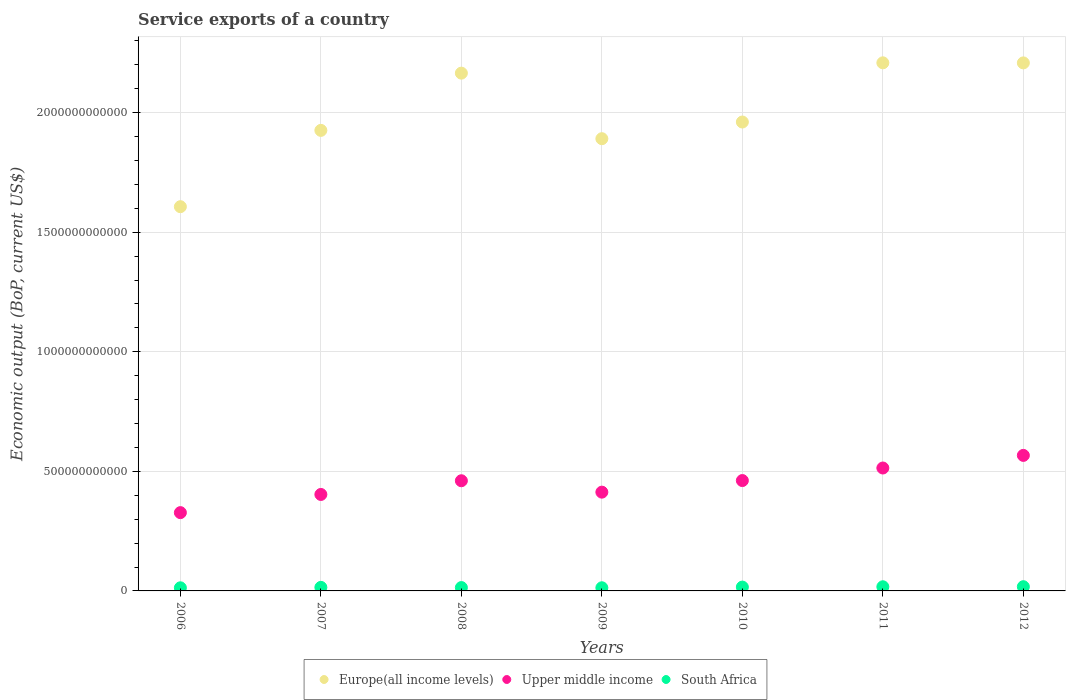How many different coloured dotlines are there?
Your response must be concise. 3. What is the service exports in Europe(all income levels) in 2012?
Provide a short and direct response. 2.21e+12. Across all years, what is the maximum service exports in Europe(all income levels)?
Your answer should be compact. 2.21e+12. Across all years, what is the minimum service exports in South Africa?
Provide a succinct answer. 1.31e+1. In which year was the service exports in South Africa minimum?
Your answer should be very brief. 2006. What is the total service exports in Europe(all income levels) in the graph?
Give a very brief answer. 1.40e+13. What is the difference between the service exports in Upper middle income in 2011 and that in 2012?
Keep it short and to the point. -5.27e+1. What is the difference between the service exports in South Africa in 2006 and the service exports in Upper middle income in 2010?
Your response must be concise. -4.48e+11. What is the average service exports in Europe(all income levels) per year?
Provide a short and direct response. 2.00e+12. In the year 2011, what is the difference between the service exports in Europe(all income levels) and service exports in Upper middle income?
Offer a terse response. 1.69e+12. What is the ratio of the service exports in Europe(all income levels) in 2008 to that in 2012?
Make the answer very short. 0.98. Is the service exports in Upper middle income in 2007 less than that in 2010?
Provide a succinct answer. Yes. Is the difference between the service exports in Europe(all income levels) in 2006 and 2008 greater than the difference between the service exports in Upper middle income in 2006 and 2008?
Your response must be concise. No. What is the difference between the highest and the second highest service exports in Upper middle income?
Your answer should be compact. 5.27e+1. What is the difference between the highest and the lowest service exports in Upper middle income?
Provide a succinct answer. 2.39e+11. Is it the case that in every year, the sum of the service exports in Europe(all income levels) and service exports in South Africa  is greater than the service exports in Upper middle income?
Your answer should be very brief. Yes. Is the service exports in Upper middle income strictly greater than the service exports in South Africa over the years?
Give a very brief answer. Yes. Is the service exports in Upper middle income strictly less than the service exports in South Africa over the years?
Ensure brevity in your answer.  No. How many dotlines are there?
Ensure brevity in your answer.  3. How many years are there in the graph?
Your response must be concise. 7. What is the difference between two consecutive major ticks on the Y-axis?
Keep it short and to the point. 5.00e+11. Are the values on the major ticks of Y-axis written in scientific E-notation?
Provide a short and direct response. No. Does the graph contain any zero values?
Provide a short and direct response. No. Does the graph contain grids?
Keep it short and to the point. Yes. How many legend labels are there?
Keep it short and to the point. 3. What is the title of the graph?
Offer a terse response. Service exports of a country. What is the label or title of the Y-axis?
Make the answer very short. Economic output (BoP, current US$). What is the Economic output (BoP, current US$) of Europe(all income levels) in 2006?
Provide a short and direct response. 1.61e+12. What is the Economic output (BoP, current US$) of Upper middle income in 2006?
Your answer should be very brief. 3.27e+11. What is the Economic output (BoP, current US$) of South Africa in 2006?
Offer a terse response. 1.31e+1. What is the Economic output (BoP, current US$) in Europe(all income levels) in 2007?
Ensure brevity in your answer.  1.93e+12. What is the Economic output (BoP, current US$) of Upper middle income in 2007?
Offer a very short reply. 4.03e+11. What is the Economic output (BoP, current US$) in South Africa in 2007?
Your answer should be compact. 1.48e+1. What is the Economic output (BoP, current US$) in Europe(all income levels) in 2008?
Give a very brief answer. 2.17e+12. What is the Economic output (BoP, current US$) in Upper middle income in 2008?
Give a very brief answer. 4.61e+11. What is the Economic output (BoP, current US$) in South Africa in 2008?
Your answer should be compact. 1.40e+1. What is the Economic output (BoP, current US$) in Europe(all income levels) in 2009?
Keep it short and to the point. 1.89e+12. What is the Economic output (BoP, current US$) in Upper middle income in 2009?
Your answer should be very brief. 4.13e+11. What is the Economic output (BoP, current US$) in South Africa in 2009?
Provide a succinct answer. 1.32e+1. What is the Economic output (BoP, current US$) in Europe(all income levels) in 2010?
Ensure brevity in your answer.  1.96e+12. What is the Economic output (BoP, current US$) of Upper middle income in 2010?
Your response must be concise. 4.62e+11. What is the Economic output (BoP, current US$) in South Africa in 2010?
Offer a very short reply. 1.61e+1. What is the Economic output (BoP, current US$) of Europe(all income levels) in 2011?
Keep it short and to the point. 2.21e+12. What is the Economic output (BoP, current US$) in Upper middle income in 2011?
Provide a succinct answer. 5.14e+11. What is the Economic output (BoP, current US$) of South Africa in 2011?
Give a very brief answer. 1.73e+1. What is the Economic output (BoP, current US$) in Europe(all income levels) in 2012?
Provide a succinct answer. 2.21e+12. What is the Economic output (BoP, current US$) in Upper middle income in 2012?
Your answer should be very brief. 5.67e+11. What is the Economic output (BoP, current US$) of South Africa in 2012?
Your answer should be very brief. 1.76e+1. Across all years, what is the maximum Economic output (BoP, current US$) of Europe(all income levels)?
Offer a terse response. 2.21e+12. Across all years, what is the maximum Economic output (BoP, current US$) in Upper middle income?
Provide a short and direct response. 5.67e+11. Across all years, what is the maximum Economic output (BoP, current US$) of South Africa?
Your answer should be very brief. 1.76e+1. Across all years, what is the minimum Economic output (BoP, current US$) in Europe(all income levels)?
Your answer should be very brief. 1.61e+12. Across all years, what is the minimum Economic output (BoP, current US$) in Upper middle income?
Keep it short and to the point. 3.27e+11. Across all years, what is the minimum Economic output (BoP, current US$) of South Africa?
Ensure brevity in your answer.  1.31e+1. What is the total Economic output (BoP, current US$) in Europe(all income levels) in the graph?
Provide a short and direct response. 1.40e+13. What is the total Economic output (BoP, current US$) in Upper middle income in the graph?
Keep it short and to the point. 3.15e+12. What is the total Economic output (BoP, current US$) of South Africa in the graph?
Your answer should be very brief. 1.06e+11. What is the difference between the Economic output (BoP, current US$) in Europe(all income levels) in 2006 and that in 2007?
Your answer should be very brief. -3.19e+11. What is the difference between the Economic output (BoP, current US$) in Upper middle income in 2006 and that in 2007?
Offer a very short reply. -7.60e+1. What is the difference between the Economic output (BoP, current US$) of South Africa in 2006 and that in 2007?
Make the answer very short. -1.78e+09. What is the difference between the Economic output (BoP, current US$) of Europe(all income levels) in 2006 and that in 2008?
Ensure brevity in your answer.  -5.58e+11. What is the difference between the Economic output (BoP, current US$) in Upper middle income in 2006 and that in 2008?
Offer a very short reply. -1.33e+11. What is the difference between the Economic output (BoP, current US$) of South Africa in 2006 and that in 2008?
Keep it short and to the point. -9.40e+08. What is the difference between the Economic output (BoP, current US$) of Europe(all income levels) in 2006 and that in 2009?
Offer a very short reply. -2.84e+11. What is the difference between the Economic output (BoP, current US$) in Upper middle income in 2006 and that in 2009?
Provide a short and direct response. -8.56e+1. What is the difference between the Economic output (BoP, current US$) of South Africa in 2006 and that in 2009?
Ensure brevity in your answer.  -1.42e+08. What is the difference between the Economic output (BoP, current US$) of Europe(all income levels) in 2006 and that in 2010?
Give a very brief answer. -3.54e+11. What is the difference between the Economic output (BoP, current US$) of Upper middle income in 2006 and that in 2010?
Offer a very short reply. -1.34e+11. What is the difference between the Economic output (BoP, current US$) of South Africa in 2006 and that in 2010?
Ensure brevity in your answer.  -3.00e+09. What is the difference between the Economic output (BoP, current US$) of Europe(all income levels) in 2006 and that in 2011?
Offer a terse response. -6.02e+11. What is the difference between the Economic output (BoP, current US$) of Upper middle income in 2006 and that in 2011?
Offer a terse response. -1.87e+11. What is the difference between the Economic output (BoP, current US$) of South Africa in 2006 and that in 2011?
Your response must be concise. -4.29e+09. What is the difference between the Economic output (BoP, current US$) of Europe(all income levels) in 2006 and that in 2012?
Your response must be concise. -6.01e+11. What is the difference between the Economic output (BoP, current US$) of Upper middle income in 2006 and that in 2012?
Your answer should be very brief. -2.39e+11. What is the difference between the Economic output (BoP, current US$) of South Africa in 2006 and that in 2012?
Provide a succinct answer. -4.58e+09. What is the difference between the Economic output (BoP, current US$) in Europe(all income levels) in 2007 and that in 2008?
Offer a very short reply. -2.39e+11. What is the difference between the Economic output (BoP, current US$) in Upper middle income in 2007 and that in 2008?
Give a very brief answer. -5.73e+1. What is the difference between the Economic output (BoP, current US$) in South Africa in 2007 and that in 2008?
Your answer should be very brief. 8.41e+08. What is the difference between the Economic output (BoP, current US$) in Europe(all income levels) in 2007 and that in 2009?
Your answer should be compact. 3.47e+1. What is the difference between the Economic output (BoP, current US$) in Upper middle income in 2007 and that in 2009?
Your response must be concise. -9.65e+09. What is the difference between the Economic output (BoP, current US$) of South Africa in 2007 and that in 2009?
Your response must be concise. 1.64e+09. What is the difference between the Economic output (BoP, current US$) of Europe(all income levels) in 2007 and that in 2010?
Keep it short and to the point. -3.50e+1. What is the difference between the Economic output (BoP, current US$) in Upper middle income in 2007 and that in 2010?
Your answer should be compact. -5.81e+1. What is the difference between the Economic output (BoP, current US$) in South Africa in 2007 and that in 2010?
Keep it short and to the point. -1.22e+09. What is the difference between the Economic output (BoP, current US$) of Europe(all income levels) in 2007 and that in 2011?
Your answer should be very brief. -2.83e+11. What is the difference between the Economic output (BoP, current US$) of Upper middle income in 2007 and that in 2011?
Make the answer very short. -1.11e+11. What is the difference between the Economic output (BoP, current US$) of South Africa in 2007 and that in 2011?
Offer a terse response. -2.51e+09. What is the difference between the Economic output (BoP, current US$) in Europe(all income levels) in 2007 and that in 2012?
Your answer should be compact. -2.82e+11. What is the difference between the Economic output (BoP, current US$) of Upper middle income in 2007 and that in 2012?
Provide a succinct answer. -1.63e+11. What is the difference between the Economic output (BoP, current US$) of South Africa in 2007 and that in 2012?
Your response must be concise. -2.80e+09. What is the difference between the Economic output (BoP, current US$) in Europe(all income levels) in 2008 and that in 2009?
Your answer should be compact. 2.74e+11. What is the difference between the Economic output (BoP, current US$) of Upper middle income in 2008 and that in 2009?
Your answer should be very brief. 4.77e+1. What is the difference between the Economic output (BoP, current US$) in South Africa in 2008 and that in 2009?
Your answer should be very brief. 7.98e+08. What is the difference between the Economic output (BoP, current US$) of Europe(all income levels) in 2008 and that in 2010?
Make the answer very short. 2.04e+11. What is the difference between the Economic output (BoP, current US$) in Upper middle income in 2008 and that in 2010?
Your response must be concise. -8.05e+08. What is the difference between the Economic output (BoP, current US$) of South Africa in 2008 and that in 2010?
Keep it short and to the point. -2.06e+09. What is the difference between the Economic output (BoP, current US$) in Europe(all income levels) in 2008 and that in 2011?
Offer a terse response. -4.32e+1. What is the difference between the Economic output (BoP, current US$) of Upper middle income in 2008 and that in 2011?
Your answer should be compact. -5.33e+1. What is the difference between the Economic output (BoP, current US$) in South Africa in 2008 and that in 2011?
Your answer should be compact. -3.35e+09. What is the difference between the Economic output (BoP, current US$) of Europe(all income levels) in 2008 and that in 2012?
Provide a succinct answer. -4.28e+1. What is the difference between the Economic output (BoP, current US$) in Upper middle income in 2008 and that in 2012?
Make the answer very short. -1.06e+11. What is the difference between the Economic output (BoP, current US$) in South Africa in 2008 and that in 2012?
Your answer should be compact. -3.64e+09. What is the difference between the Economic output (BoP, current US$) in Europe(all income levels) in 2009 and that in 2010?
Provide a succinct answer. -6.97e+1. What is the difference between the Economic output (BoP, current US$) of Upper middle income in 2009 and that in 2010?
Ensure brevity in your answer.  -4.85e+1. What is the difference between the Economic output (BoP, current US$) of South Africa in 2009 and that in 2010?
Make the answer very short. -2.86e+09. What is the difference between the Economic output (BoP, current US$) in Europe(all income levels) in 2009 and that in 2011?
Keep it short and to the point. -3.17e+11. What is the difference between the Economic output (BoP, current US$) in Upper middle income in 2009 and that in 2011?
Provide a short and direct response. -1.01e+11. What is the difference between the Economic output (BoP, current US$) in South Africa in 2009 and that in 2011?
Your answer should be compact. -4.15e+09. What is the difference between the Economic output (BoP, current US$) of Europe(all income levels) in 2009 and that in 2012?
Offer a very short reply. -3.17e+11. What is the difference between the Economic output (BoP, current US$) in Upper middle income in 2009 and that in 2012?
Provide a short and direct response. -1.54e+11. What is the difference between the Economic output (BoP, current US$) of South Africa in 2009 and that in 2012?
Offer a very short reply. -4.44e+09. What is the difference between the Economic output (BoP, current US$) of Europe(all income levels) in 2010 and that in 2011?
Your answer should be compact. -2.48e+11. What is the difference between the Economic output (BoP, current US$) of Upper middle income in 2010 and that in 2011?
Offer a very short reply. -5.25e+1. What is the difference between the Economic output (BoP, current US$) of South Africa in 2010 and that in 2011?
Make the answer very short. -1.28e+09. What is the difference between the Economic output (BoP, current US$) in Europe(all income levels) in 2010 and that in 2012?
Provide a short and direct response. -2.47e+11. What is the difference between the Economic output (BoP, current US$) of Upper middle income in 2010 and that in 2012?
Keep it short and to the point. -1.05e+11. What is the difference between the Economic output (BoP, current US$) of South Africa in 2010 and that in 2012?
Offer a terse response. -1.58e+09. What is the difference between the Economic output (BoP, current US$) in Europe(all income levels) in 2011 and that in 2012?
Your answer should be compact. 3.03e+08. What is the difference between the Economic output (BoP, current US$) of Upper middle income in 2011 and that in 2012?
Provide a succinct answer. -5.27e+1. What is the difference between the Economic output (BoP, current US$) in South Africa in 2011 and that in 2012?
Your answer should be very brief. -2.93e+08. What is the difference between the Economic output (BoP, current US$) of Europe(all income levels) in 2006 and the Economic output (BoP, current US$) of Upper middle income in 2007?
Ensure brevity in your answer.  1.20e+12. What is the difference between the Economic output (BoP, current US$) in Europe(all income levels) in 2006 and the Economic output (BoP, current US$) in South Africa in 2007?
Provide a short and direct response. 1.59e+12. What is the difference between the Economic output (BoP, current US$) of Upper middle income in 2006 and the Economic output (BoP, current US$) of South Africa in 2007?
Ensure brevity in your answer.  3.13e+11. What is the difference between the Economic output (BoP, current US$) in Europe(all income levels) in 2006 and the Economic output (BoP, current US$) in Upper middle income in 2008?
Keep it short and to the point. 1.15e+12. What is the difference between the Economic output (BoP, current US$) of Europe(all income levels) in 2006 and the Economic output (BoP, current US$) of South Africa in 2008?
Provide a succinct answer. 1.59e+12. What is the difference between the Economic output (BoP, current US$) of Upper middle income in 2006 and the Economic output (BoP, current US$) of South Africa in 2008?
Your answer should be very brief. 3.13e+11. What is the difference between the Economic output (BoP, current US$) of Europe(all income levels) in 2006 and the Economic output (BoP, current US$) of Upper middle income in 2009?
Provide a short and direct response. 1.19e+12. What is the difference between the Economic output (BoP, current US$) of Europe(all income levels) in 2006 and the Economic output (BoP, current US$) of South Africa in 2009?
Your answer should be very brief. 1.59e+12. What is the difference between the Economic output (BoP, current US$) in Upper middle income in 2006 and the Economic output (BoP, current US$) in South Africa in 2009?
Give a very brief answer. 3.14e+11. What is the difference between the Economic output (BoP, current US$) of Europe(all income levels) in 2006 and the Economic output (BoP, current US$) of Upper middle income in 2010?
Offer a terse response. 1.15e+12. What is the difference between the Economic output (BoP, current US$) in Europe(all income levels) in 2006 and the Economic output (BoP, current US$) in South Africa in 2010?
Provide a succinct answer. 1.59e+12. What is the difference between the Economic output (BoP, current US$) in Upper middle income in 2006 and the Economic output (BoP, current US$) in South Africa in 2010?
Ensure brevity in your answer.  3.11e+11. What is the difference between the Economic output (BoP, current US$) of Europe(all income levels) in 2006 and the Economic output (BoP, current US$) of Upper middle income in 2011?
Your response must be concise. 1.09e+12. What is the difference between the Economic output (BoP, current US$) of Europe(all income levels) in 2006 and the Economic output (BoP, current US$) of South Africa in 2011?
Your answer should be compact. 1.59e+12. What is the difference between the Economic output (BoP, current US$) of Upper middle income in 2006 and the Economic output (BoP, current US$) of South Africa in 2011?
Offer a very short reply. 3.10e+11. What is the difference between the Economic output (BoP, current US$) in Europe(all income levels) in 2006 and the Economic output (BoP, current US$) in Upper middle income in 2012?
Offer a very short reply. 1.04e+12. What is the difference between the Economic output (BoP, current US$) of Europe(all income levels) in 2006 and the Economic output (BoP, current US$) of South Africa in 2012?
Offer a terse response. 1.59e+12. What is the difference between the Economic output (BoP, current US$) of Upper middle income in 2006 and the Economic output (BoP, current US$) of South Africa in 2012?
Make the answer very short. 3.10e+11. What is the difference between the Economic output (BoP, current US$) of Europe(all income levels) in 2007 and the Economic output (BoP, current US$) of Upper middle income in 2008?
Ensure brevity in your answer.  1.47e+12. What is the difference between the Economic output (BoP, current US$) in Europe(all income levels) in 2007 and the Economic output (BoP, current US$) in South Africa in 2008?
Provide a short and direct response. 1.91e+12. What is the difference between the Economic output (BoP, current US$) in Upper middle income in 2007 and the Economic output (BoP, current US$) in South Africa in 2008?
Your answer should be very brief. 3.89e+11. What is the difference between the Economic output (BoP, current US$) in Europe(all income levels) in 2007 and the Economic output (BoP, current US$) in Upper middle income in 2009?
Offer a very short reply. 1.51e+12. What is the difference between the Economic output (BoP, current US$) of Europe(all income levels) in 2007 and the Economic output (BoP, current US$) of South Africa in 2009?
Your answer should be very brief. 1.91e+12. What is the difference between the Economic output (BoP, current US$) of Upper middle income in 2007 and the Economic output (BoP, current US$) of South Africa in 2009?
Your response must be concise. 3.90e+11. What is the difference between the Economic output (BoP, current US$) of Europe(all income levels) in 2007 and the Economic output (BoP, current US$) of Upper middle income in 2010?
Give a very brief answer. 1.46e+12. What is the difference between the Economic output (BoP, current US$) in Europe(all income levels) in 2007 and the Economic output (BoP, current US$) in South Africa in 2010?
Make the answer very short. 1.91e+12. What is the difference between the Economic output (BoP, current US$) of Upper middle income in 2007 and the Economic output (BoP, current US$) of South Africa in 2010?
Offer a terse response. 3.87e+11. What is the difference between the Economic output (BoP, current US$) of Europe(all income levels) in 2007 and the Economic output (BoP, current US$) of Upper middle income in 2011?
Your answer should be compact. 1.41e+12. What is the difference between the Economic output (BoP, current US$) in Europe(all income levels) in 2007 and the Economic output (BoP, current US$) in South Africa in 2011?
Make the answer very short. 1.91e+12. What is the difference between the Economic output (BoP, current US$) of Upper middle income in 2007 and the Economic output (BoP, current US$) of South Africa in 2011?
Give a very brief answer. 3.86e+11. What is the difference between the Economic output (BoP, current US$) of Europe(all income levels) in 2007 and the Economic output (BoP, current US$) of Upper middle income in 2012?
Keep it short and to the point. 1.36e+12. What is the difference between the Economic output (BoP, current US$) in Europe(all income levels) in 2007 and the Economic output (BoP, current US$) in South Africa in 2012?
Provide a short and direct response. 1.91e+12. What is the difference between the Economic output (BoP, current US$) in Upper middle income in 2007 and the Economic output (BoP, current US$) in South Africa in 2012?
Offer a very short reply. 3.86e+11. What is the difference between the Economic output (BoP, current US$) of Europe(all income levels) in 2008 and the Economic output (BoP, current US$) of Upper middle income in 2009?
Ensure brevity in your answer.  1.75e+12. What is the difference between the Economic output (BoP, current US$) in Europe(all income levels) in 2008 and the Economic output (BoP, current US$) in South Africa in 2009?
Ensure brevity in your answer.  2.15e+12. What is the difference between the Economic output (BoP, current US$) in Upper middle income in 2008 and the Economic output (BoP, current US$) in South Africa in 2009?
Provide a short and direct response. 4.48e+11. What is the difference between the Economic output (BoP, current US$) in Europe(all income levels) in 2008 and the Economic output (BoP, current US$) in Upper middle income in 2010?
Ensure brevity in your answer.  1.70e+12. What is the difference between the Economic output (BoP, current US$) of Europe(all income levels) in 2008 and the Economic output (BoP, current US$) of South Africa in 2010?
Your answer should be compact. 2.15e+12. What is the difference between the Economic output (BoP, current US$) of Upper middle income in 2008 and the Economic output (BoP, current US$) of South Africa in 2010?
Your answer should be compact. 4.45e+11. What is the difference between the Economic output (BoP, current US$) in Europe(all income levels) in 2008 and the Economic output (BoP, current US$) in Upper middle income in 2011?
Ensure brevity in your answer.  1.65e+12. What is the difference between the Economic output (BoP, current US$) in Europe(all income levels) in 2008 and the Economic output (BoP, current US$) in South Africa in 2011?
Your answer should be compact. 2.15e+12. What is the difference between the Economic output (BoP, current US$) of Upper middle income in 2008 and the Economic output (BoP, current US$) of South Africa in 2011?
Your answer should be compact. 4.43e+11. What is the difference between the Economic output (BoP, current US$) in Europe(all income levels) in 2008 and the Economic output (BoP, current US$) in Upper middle income in 2012?
Provide a short and direct response. 1.60e+12. What is the difference between the Economic output (BoP, current US$) of Europe(all income levels) in 2008 and the Economic output (BoP, current US$) of South Africa in 2012?
Your answer should be compact. 2.15e+12. What is the difference between the Economic output (BoP, current US$) of Upper middle income in 2008 and the Economic output (BoP, current US$) of South Africa in 2012?
Ensure brevity in your answer.  4.43e+11. What is the difference between the Economic output (BoP, current US$) in Europe(all income levels) in 2009 and the Economic output (BoP, current US$) in Upper middle income in 2010?
Provide a succinct answer. 1.43e+12. What is the difference between the Economic output (BoP, current US$) in Europe(all income levels) in 2009 and the Economic output (BoP, current US$) in South Africa in 2010?
Give a very brief answer. 1.88e+12. What is the difference between the Economic output (BoP, current US$) in Upper middle income in 2009 and the Economic output (BoP, current US$) in South Africa in 2010?
Offer a terse response. 3.97e+11. What is the difference between the Economic output (BoP, current US$) in Europe(all income levels) in 2009 and the Economic output (BoP, current US$) in Upper middle income in 2011?
Your response must be concise. 1.38e+12. What is the difference between the Economic output (BoP, current US$) in Europe(all income levels) in 2009 and the Economic output (BoP, current US$) in South Africa in 2011?
Ensure brevity in your answer.  1.87e+12. What is the difference between the Economic output (BoP, current US$) of Upper middle income in 2009 and the Economic output (BoP, current US$) of South Africa in 2011?
Offer a very short reply. 3.96e+11. What is the difference between the Economic output (BoP, current US$) in Europe(all income levels) in 2009 and the Economic output (BoP, current US$) in Upper middle income in 2012?
Ensure brevity in your answer.  1.32e+12. What is the difference between the Economic output (BoP, current US$) of Europe(all income levels) in 2009 and the Economic output (BoP, current US$) of South Africa in 2012?
Make the answer very short. 1.87e+12. What is the difference between the Economic output (BoP, current US$) of Upper middle income in 2009 and the Economic output (BoP, current US$) of South Africa in 2012?
Make the answer very short. 3.95e+11. What is the difference between the Economic output (BoP, current US$) of Europe(all income levels) in 2010 and the Economic output (BoP, current US$) of Upper middle income in 2011?
Offer a terse response. 1.45e+12. What is the difference between the Economic output (BoP, current US$) of Europe(all income levels) in 2010 and the Economic output (BoP, current US$) of South Africa in 2011?
Ensure brevity in your answer.  1.94e+12. What is the difference between the Economic output (BoP, current US$) of Upper middle income in 2010 and the Economic output (BoP, current US$) of South Africa in 2011?
Your response must be concise. 4.44e+11. What is the difference between the Economic output (BoP, current US$) of Europe(all income levels) in 2010 and the Economic output (BoP, current US$) of Upper middle income in 2012?
Your answer should be compact. 1.39e+12. What is the difference between the Economic output (BoP, current US$) in Europe(all income levels) in 2010 and the Economic output (BoP, current US$) in South Africa in 2012?
Give a very brief answer. 1.94e+12. What is the difference between the Economic output (BoP, current US$) of Upper middle income in 2010 and the Economic output (BoP, current US$) of South Africa in 2012?
Ensure brevity in your answer.  4.44e+11. What is the difference between the Economic output (BoP, current US$) in Europe(all income levels) in 2011 and the Economic output (BoP, current US$) in Upper middle income in 2012?
Your response must be concise. 1.64e+12. What is the difference between the Economic output (BoP, current US$) in Europe(all income levels) in 2011 and the Economic output (BoP, current US$) in South Africa in 2012?
Give a very brief answer. 2.19e+12. What is the difference between the Economic output (BoP, current US$) of Upper middle income in 2011 and the Economic output (BoP, current US$) of South Africa in 2012?
Offer a terse response. 4.96e+11. What is the average Economic output (BoP, current US$) of Europe(all income levels) per year?
Your response must be concise. 2.00e+12. What is the average Economic output (BoP, current US$) of Upper middle income per year?
Keep it short and to the point. 4.50e+11. What is the average Economic output (BoP, current US$) in South Africa per year?
Ensure brevity in your answer.  1.52e+1. In the year 2006, what is the difference between the Economic output (BoP, current US$) of Europe(all income levels) and Economic output (BoP, current US$) of Upper middle income?
Offer a terse response. 1.28e+12. In the year 2006, what is the difference between the Economic output (BoP, current US$) in Europe(all income levels) and Economic output (BoP, current US$) in South Africa?
Ensure brevity in your answer.  1.59e+12. In the year 2006, what is the difference between the Economic output (BoP, current US$) in Upper middle income and Economic output (BoP, current US$) in South Africa?
Your answer should be compact. 3.14e+11. In the year 2007, what is the difference between the Economic output (BoP, current US$) in Europe(all income levels) and Economic output (BoP, current US$) in Upper middle income?
Provide a succinct answer. 1.52e+12. In the year 2007, what is the difference between the Economic output (BoP, current US$) in Europe(all income levels) and Economic output (BoP, current US$) in South Africa?
Provide a short and direct response. 1.91e+12. In the year 2007, what is the difference between the Economic output (BoP, current US$) in Upper middle income and Economic output (BoP, current US$) in South Africa?
Offer a terse response. 3.89e+11. In the year 2008, what is the difference between the Economic output (BoP, current US$) in Europe(all income levels) and Economic output (BoP, current US$) in Upper middle income?
Your response must be concise. 1.70e+12. In the year 2008, what is the difference between the Economic output (BoP, current US$) of Europe(all income levels) and Economic output (BoP, current US$) of South Africa?
Offer a terse response. 2.15e+12. In the year 2008, what is the difference between the Economic output (BoP, current US$) of Upper middle income and Economic output (BoP, current US$) of South Africa?
Ensure brevity in your answer.  4.47e+11. In the year 2009, what is the difference between the Economic output (BoP, current US$) of Europe(all income levels) and Economic output (BoP, current US$) of Upper middle income?
Give a very brief answer. 1.48e+12. In the year 2009, what is the difference between the Economic output (BoP, current US$) of Europe(all income levels) and Economic output (BoP, current US$) of South Africa?
Give a very brief answer. 1.88e+12. In the year 2009, what is the difference between the Economic output (BoP, current US$) in Upper middle income and Economic output (BoP, current US$) in South Africa?
Provide a succinct answer. 4.00e+11. In the year 2010, what is the difference between the Economic output (BoP, current US$) in Europe(all income levels) and Economic output (BoP, current US$) in Upper middle income?
Your answer should be compact. 1.50e+12. In the year 2010, what is the difference between the Economic output (BoP, current US$) in Europe(all income levels) and Economic output (BoP, current US$) in South Africa?
Give a very brief answer. 1.94e+12. In the year 2010, what is the difference between the Economic output (BoP, current US$) of Upper middle income and Economic output (BoP, current US$) of South Africa?
Offer a terse response. 4.45e+11. In the year 2011, what is the difference between the Economic output (BoP, current US$) of Europe(all income levels) and Economic output (BoP, current US$) of Upper middle income?
Keep it short and to the point. 1.69e+12. In the year 2011, what is the difference between the Economic output (BoP, current US$) of Europe(all income levels) and Economic output (BoP, current US$) of South Africa?
Provide a succinct answer. 2.19e+12. In the year 2011, what is the difference between the Economic output (BoP, current US$) in Upper middle income and Economic output (BoP, current US$) in South Africa?
Provide a succinct answer. 4.97e+11. In the year 2012, what is the difference between the Economic output (BoP, current US$) in Europe(all income levels) and Economic output (BoP, current US$) in Upper middle income?
Offer a very short reply. 1.64e+12. In the year 2012, what is the difference between the Economic output (BoP, current US$) in Europe(all income levels) and Economic output (BoP, current US$) in South Africa?
Your answer should be compact. 2.19e+12. In the year 2012, what is the difference between the Economic output (BoP, current US$) in Upper middle income and Economic output (BoP, current US$) in South Africa?
Your response must be concise. 5.49e+11. What is the ratio of the Economic output (BoP, current US$) in Europe(all income levels) in 2006 to that in 2007?
Provide a short and direct response. 0.83. What is the ratio of the Economic output (BoP, current US$) in Upper middle income in 2006 to that in 2007?
Offer a very short reply. 0.81. What is the ratio of the Economic output (BoP, current US$) in South Africa in 2006 to that in 2007?
Your response must be concise. 0.88. What is the ratio of the Economic output (BoP, current US$) in Europe(all income levels) in 2006 to that in 2008?
Keep it short and to the point. 0.74. What is the ratio of the Economic output (BoP, current US$) of Upper middle income in 2006 to that in 2008?
Your answer should be very brief. 0.71. What is the ratio of the Economic output (BoP, current US$) of South Africa in 2006 to that in 2008?
Provide a short and direct response. 0.93. What is the ratio of the Economic output (BoP, current US$) of Europe(all income levels) in 2006 to that in 2009?
Provide a succinct answer. 0.85. What is the ratio of the Economic output (BoP, current US$) of Upper middle income in 2006 to that in 2009?
Offer a very short reply. 0.79. What is the ratio of the Economic output (BoP, current US$) of South Africa in 2006 to that in 2009?
Your answer should be very brief. 0.99. What is the ratio of the Economic output (BoP, current US$) in Europe(all income levels) in 2006 to that in 2010?
Give a very brief answer. 0.82. What is the ratio of the Economic output (BoP, current US$) of Upper middle income in 2006 to that in 2010?
Offer a very short reply. 0.71. What is the ratio of the Economic output (BoP, current US$) in South Africa in 2006 to that in 2010?
Give a very brief answer. 0.81. What is the ratio of the Economic output (BoP, current US$) in Europe(all income levels) in 2006 to that in 2011?
Ensure brevity in your answer.  0.73. What is the ratio of the Economic output (BoP, current US$) in Upper middle income in 2006 to that in 2011?
Your response must be concise. 0.64. What is the ratio of the Economic output (BoP, current US$) in South Africa in 2006 to that in 2011?
Your answer should be compact. 0.75. What is the ratio of the Economic output (BoP, current US$) in Europe(all income levels) in 2006 to that in 2012?
Your answer should be very brief. 0.73. What is the ratio of the Economic output (BoP, current US$) in Upper middle income in 2006 to that in 2012?
Provide a short and direct response. 0.58. What is the ratio of the Economic output (BoP, current US$) of South Africa in 2006 to that in 2012?
Your answer should be very brief. 0.74. What is the ratio of the Economic output (BoP, current US$) of Europe(all income levels) in 2007 to that in 2008?
Your answer should be compact. 0.89. What is the ratio of the Economic output (BoP, current US$) in Upper middle income in 2007 to that in 2008?
Your response must be concise. 0.88. What is the ratio of the Economic output (BoP, current US$) in South Africa in 2007 to that in 2008?
Give a very brief answer. 1.06. What is the ratio of the Economic output (BoP, current US$) of Europe(all income levels) in 2007 to that in 2009?
Your answer should be compact. 1.02. What is the ratio of the Economic output (BoP, current US$) in Upper middle income in 2007 to that in 2009?
Offer a terse response. 0.98. What is the ratio of the Economic output (BoP, current US$) in South Africa in 2007 to that in 2009?
Your response must be concise. 1.12. What is the ratio of the Economic output (BoP, current US$) of Europe(all income levels) in 2007 to that in 2010?
Offer a very short reply. 0.98. What is the ratio of the Economic output (BoP, current US$) of Upper middle income in 2007 to that in 2010?
Your answer should be very brief. 0.87. What is the ratio of the Economic output (BoP, current US$) of South Africa in 2007 to that in 2010?
Your answer should be very brief. 0.92. What is the ratio of the Economic output (BoP, current US$) in Europe(all income levels) in 2007 to that in 2011?
Provide a succinct answer. 0.87. What is the ratio of the Economic output (BoP, current US$) of Upper middle income in 2007 to that in 2011?
Your response must be concise. 0.78. What is the ratio of the Economic output (BoP, current US$) of South Africa in 2007 to that in 2011?
Offer a very short reply. 0.86. What is the ratio of the Economic output (BoP, current US$) in Europe(all income levels) in 2007 to that in 2012?
Provide a short and direct response. 0.87. What is the ratio of the Economic output (BoP, current US$) in Upper middle income in 2007 to that in 2012?
Make the answer very short. 0.71. What is the ratio of the Economic output (BoP, current US$) in South Africa in 2007 to that in 2012?
Provide a short and direct response. 0.84. What is the ratio of the Economic output (BoP, current US$) in Europe(all income levels) in 2008 to that in 2009?
Your answer should be compact. 1.14. What is the ratio of the Economic output (BoP, current US$) in Upper middle income in 2008 to that in 2009?
Ensure brevity in your answer.  1.12. What is the ratio of the Economic output (BoP, current US$) in South Africa in 2008 to that in 2009?
Your answer should be very brief. 1.06. What is the ratio of the Economic output (BoP, current US$) in Europe(all income levels) in 2008 to that in 2010?
Your answer should be very brief. 1.1. What is the ratio of the Economic output (BoP, current US$) of Upper middle income in 2008 to that in 2010?
Make the answer very short. 1. What is the ratio of the Economic output (BoP, current US$) of South Africa in 2008 to that in 2010?
Provide a short and direct response. 0.87. What is the ratio of the Economic output (BoP, current US$) in Europe(all income levels) in 2008 to that in 2011?
Make the answer very short. 0.98. What is the ratio of the Economic output (BoP, current US$) of Upper middle income in 2008 to that in 2011?
Offer a terse response. 0.9. What is the ratio of the Economic output (BoP, current US$) in South Africa in 2008 to that in 2011?
Make the answer very short. 0.81. What is the ratio of the Economic output (BoP, current US$) of Europe(all income levels) in 2008 to that in 2012?
Give a very brief answer. 0.98. What is the ratio of the Economic output (BoP, current US$) of Upper middle income in 2008 to that in 2012?
Your response must be concise. 0.81. What is the ratio of the Economic output (BoP, current US$) in South Africa in 2008 to that in 2012?
Offer a very short reply. 0.79. What is the ratio of the Economic output (BoP, current US$) in Europe(all income levels) in 2009 to that in 2010?
Make the answer very short. 0.96. What is the ratio of the Economic output (BoP, current US$) in Upper middle income in 2009 to that in 2010?
Give a very brief answer. 0.9. What is the ratio of the Economic output (BoP, current US$) in South Africa in 2009 to that in 2010?
Your answer should be compact. 0.82. What is the ratio of the Economic output (BoP, current US$) in Europe(all income levels) in 2009 to that in 2011?
Provide a succinct answer. 0.86. What is the ratio of the Economic output (BoP, current US$) of Upper middle income in 2009 to that in 2011?
Provide a short and direct response. 0.8. What is the ratio of the Economic output (BoP, current US$) in South Africa in 2009 to that in 2011?
Keep it short and to the point. 0.76. What is the ratio of the Economic output (BoP, current US$) of Europe(all income levels) in 2009 to that in 2012?
Give a very brief answer. 0.86. What is the ratio of the Economic output (BoP, current US$) of Upper middle income in 2009 to that in 2012?
Your response must be concise. 0.73. What is the ratio of the Economic output (BoP, current US$) of South Africa in 2009 to that in 2012?
Your response must be concise. 0.75. What is the ratio of the Economic output (BoP, current US$) of Europe(all income levels) in 2010 to that in 2011?
Offer a very short reply. 0.89. What is the ratio of the Economic output (BoP, current US$) of Upper middle income in 2010 to that in 2011?
Provide a short and direct response. 0.9. What is the ratio of the Economic output (BoP, current US$) in South Africa in 2010 to that in 2011?
Give a very brief answer. 0.93. What is the ratio of the Economic output (BoP, current US$) of Europe(all income levels) in 2010 to that in 2012?
Keep it short and to the point. 0.89. What is the ratio of the Economic output (BoP, current US$) in Upper middle income in 2010 to that in 2012?
Your answer should be very brief. 0.81. What is the ratio of the Economic output (BoP, current US$) of South Africa in 2010 to that in 2012?
Offer a very short reply. 0.91. What is the ratio of the Economic output (BoP, current US$) in Europe(all income levels) in 2011 to that in 2012?
Ensure brevity in your answer.  1. What is the ratio of the Economic output (BoP, current US$) of Upper middle income in 2011 to that in 2012?
Your response must be concise. 0.91. What is the ratio of the Economic output (BoP, current US$) of South Africa in 2011 to that in 2012?
Your answer should be very brief. 0.98. What is the difference between the highest and the second highest Economic output (BoP, current US$) of Europe(all income levels)?
Give a very brief answer. 3.03e+08. What is the difference between the highest and the second highest Economic output (BoP, current US$) in Upper middle income?
Your answer should be compact. 5.27e+1. What is the difference between the highest and the second highest Economic output (BoP, current US$) in South Africa?
Your answer should be very brief. 2.93e+08. What is the difference between the highest and the lowest Economic output (BoP, current US$) of Europe(all income levels)?
Ensure brevity in your answer.  6.02e+11. What is the difference between the highest and the lowest Economic output (BoP, current US$) of Upper middle income?
Your answer should be compact. 2.39e+11. What is the difference between the highest and the lowest Economic output (BoP, current US$) in South Africa?
Offer a very short reply. 4.58e+09. 